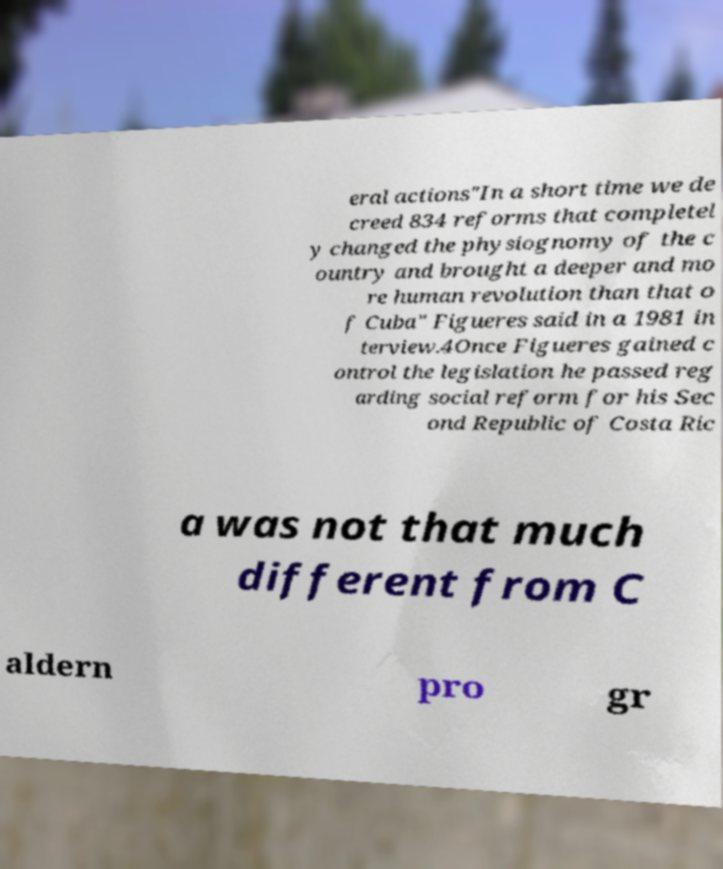Could you extract and type out the text from this image? eral actions"In a short time we de creed 834 reforms that completel y changed the physiognomy of the c ountry and brought a deeper and mo re human revolution than that o f Cuba" Figueres said in a 1981 in terview.4Once Figueres gained c ontrol the legislation he passed reg arding social reform for his Sec ond Republic of Costa Ric a was not that much different from C aldern pro gr 